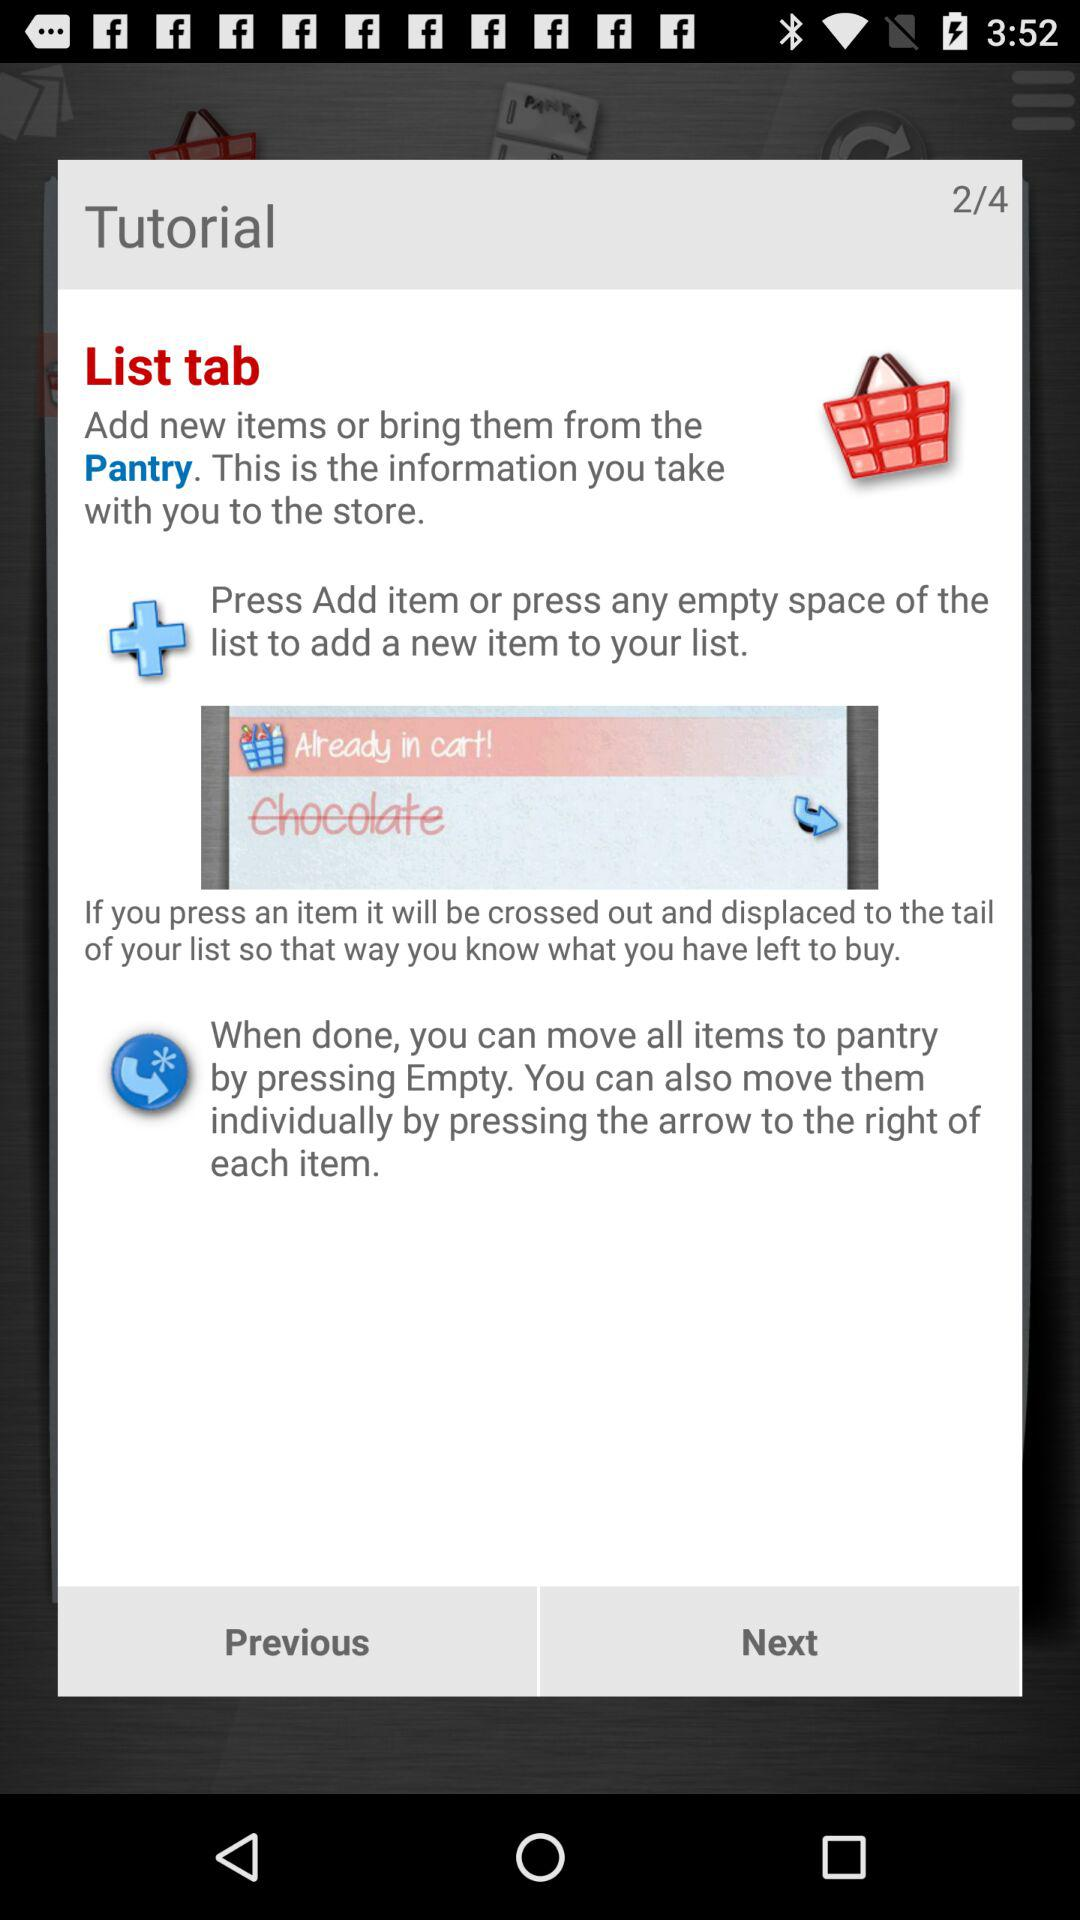How many pages are there in total? There are 4 pages in total. 